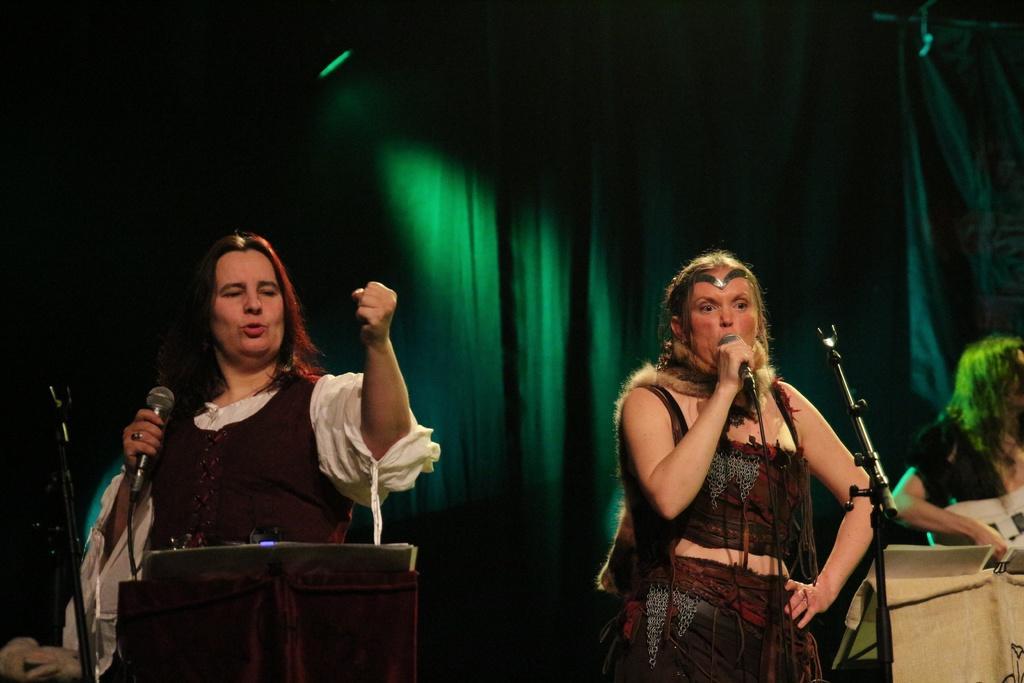Can you describe this image briefly? In this image I can see few women are standing and few of them are holding mics. I can also see they are wearing costumes. 